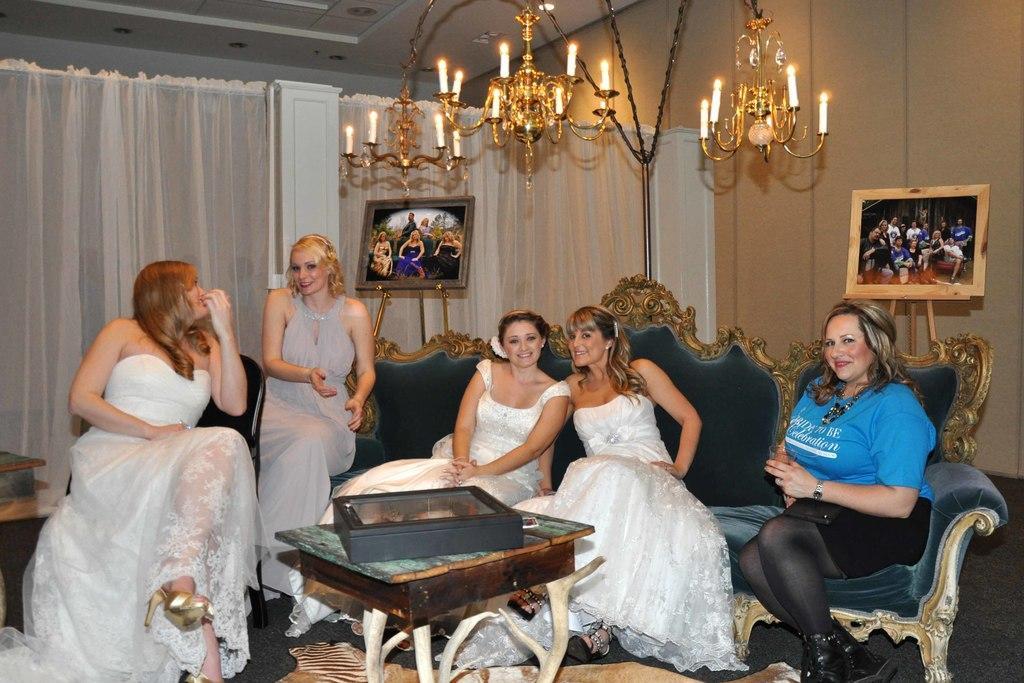How would you summarize this image in a sentence or two? In this image five women are sitting on sofa. There is a table in front of them. On top of it there is a box and back to the sofa there is a picture frame. Background there is a chandelier having candles. At the background there is curtain arranged to the wall. 